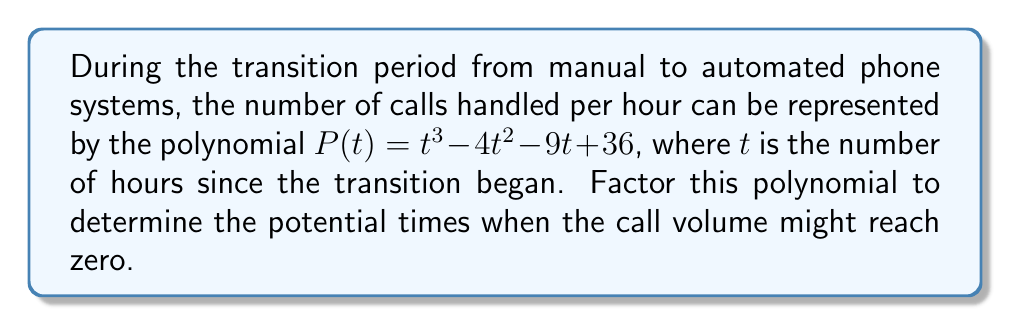Can you answer this question? To factor this polynomial, we'll follow these steps:

1) First, let's check if there's a common factor:
   $P(t) = t^3 - 4t^2 - 9t + 36$
   There's no common factor for all terms.

2) Next, we'll try to guess a rational root. The possible rational roots are the factors of the constant term: ±1, ±2, ±3, ±4, ±6, ±9, ±12, ±18, ±36.

3) Let's try $t = 3$:
   $P(3) = 3^3 - 4(3^2) - 9(3) + 36$
   $    = 27 - 36 - 27 + 36 = 0$

4) So, $(t - 3)$ is a factor. We can divide $P(t)$ by $(t - 3)$ to find the other factor:

   $$\begin{array}{r}
   t^2 - t - 12 \\
   t - 3 \enclose{longdiv}{t^3 - 4t^2 - 9t + 36} \\
   \underline{t^3 - 3t^2} \\
   -t^2 - 9t \\
   \underline{-t^2 + 3t} \\
   -12t + 36 \\
   \underline{-12t + 36}
   \end{array}$$

5) So, $P(t) = (t - 3)(t^2 - t - 12)$

6) We can factor $t^2 - t - 12$ further:
   $t^2 - t - 12 = (t - 4)(t + 3)$

Therefore, the fully factored polynomial is:
$P(t) = (t - 3)(t - 4)(t + 3)$
Answer: $(t - 3)(t - 4)(t + 3)$ 